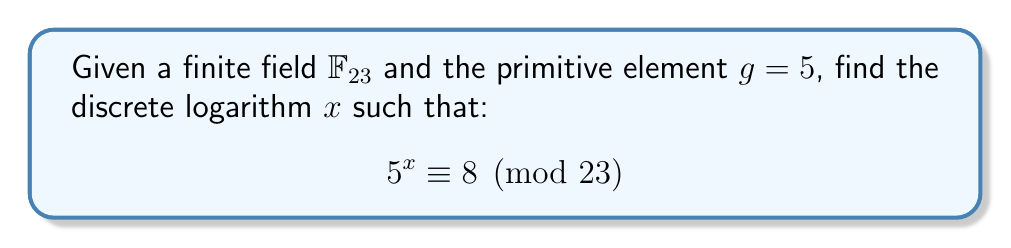Teach me how to tackle this problem. To solve this discrete logarithm problem, we'll use the baby-step giant-step algorithm, which is more efficient than brute force for medium-sized problems.

Step 1: Calculate $m = \lceil\sqrt{23}\rceil = 5$

Step 2: Compute the baby-step table:
$$\begin{array}{c|c}
j & g^j \bmod 23 \\
\hline
0 & 1 \\
1 & 5 \\
2 & 2 \\
3 & 10 \\
4 & 4 \\
\end{array}$$

Step 3: Compute $g^{-m} \bmod 23$:
$g^{-1} \bmod 23 = 14$ (using the extended Euclidean algorithm)
$g^{-m} \bmod 23 = 14^5 \bmod 23 = 18$

Step 4: Compute the giant steps:
$$\begin{array}{c|c}
i & 8 \cdot (g^{-m})^i \bmod 23 \\
\hline
0 & 8 \\
1 & 6 \\
2 & 16 \\
3 & 11 \\
4 & 13 \\
\end{array}$$

Step 5: Find a match between the baby-step and giant-step tables:
We find that $g^2 \bmod 23 = 2$ and $8 \cdot (g^{-m})^2 \bmod 23 = 16$

Step 6: Calculate $x$:
$x = 2 + 2m = 2 + 2 \cdot 5 = 12$

Verify: $5^{12} \bmod 23 = 8$
Answer: $x = 12$ 